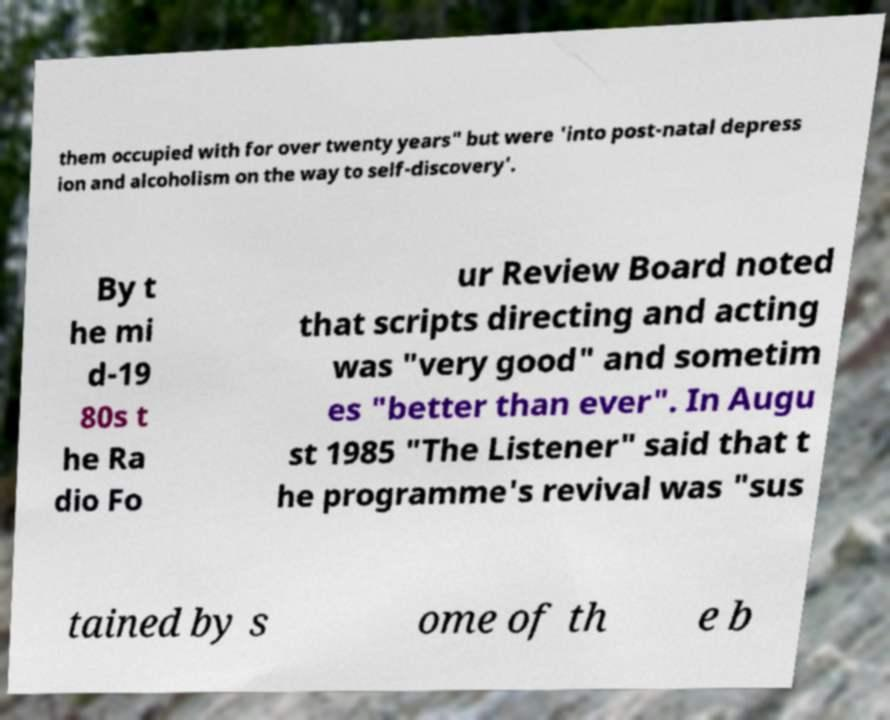Please identify and transcribe the text found in this image. them occupied with for over twenty years" but were 'into post-natal depress ion and alcoholism on the way to self-discovery'. By t he mi d-19 80s t he Ra dio Fo ur Review Board noted that scripts directing and acting was "very good" and sometim es "better than ever". In Augu st 1985 "The Listener" said that t he programme's revival was "sus tained by s ome of th e b 